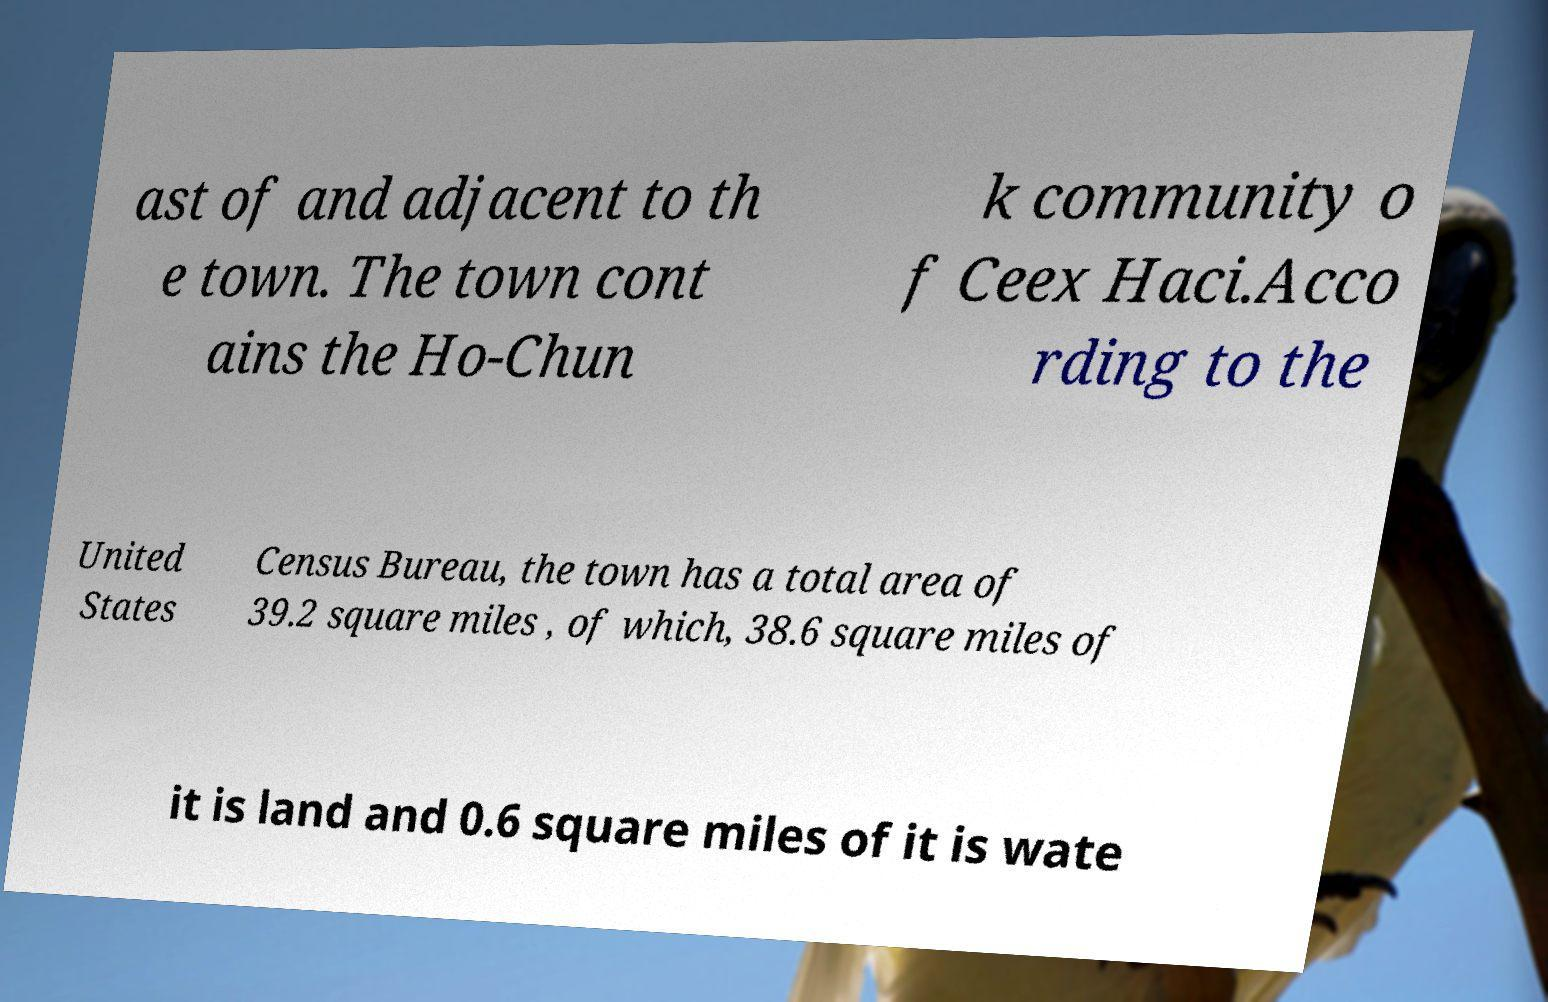What messages or text are displayed in this image? I need them in a readable, typed format. ast of and adjacent to th e town. The town cont ains the Ho-Chun k community o f Ceex Haci.Acco rding to the United States Census Bureau, the town has a total area of 39.2 square miles , of which, 38.6 square miles of it is land and 0.6 square miles of it is wate 